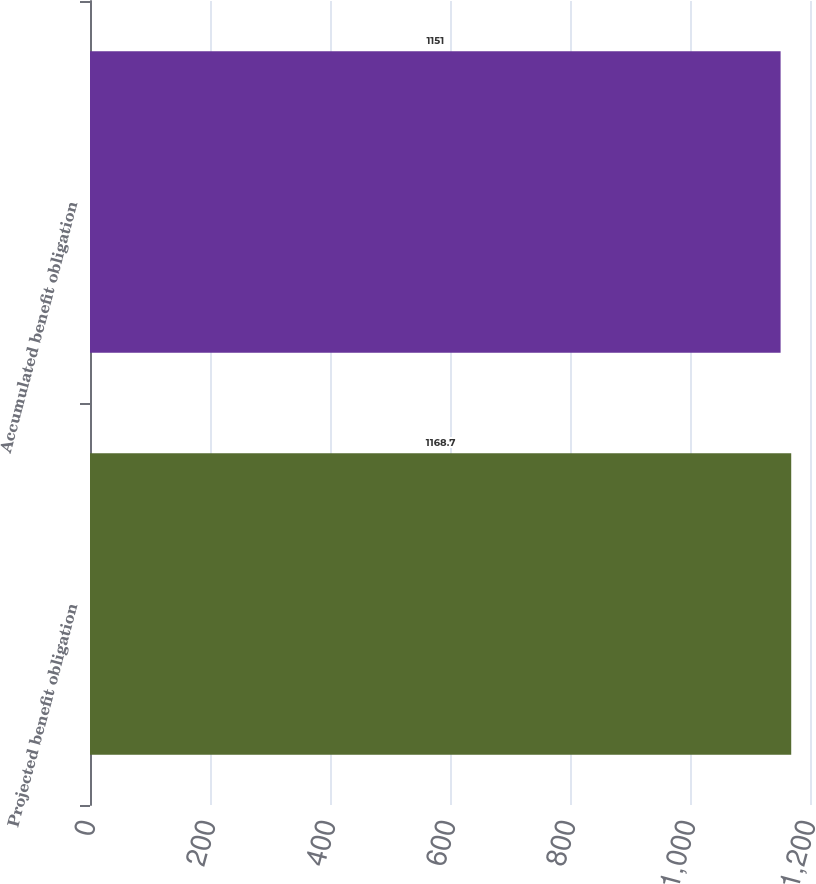Convert chart. <chart><loc_0><loc_0><loc_500><loc_500><bar_chart><fcel>Projected benefit obligation<fcel>Accumulated benefit obligation<nl><fcel>1168.7<fcel>1151<nl></chart> 